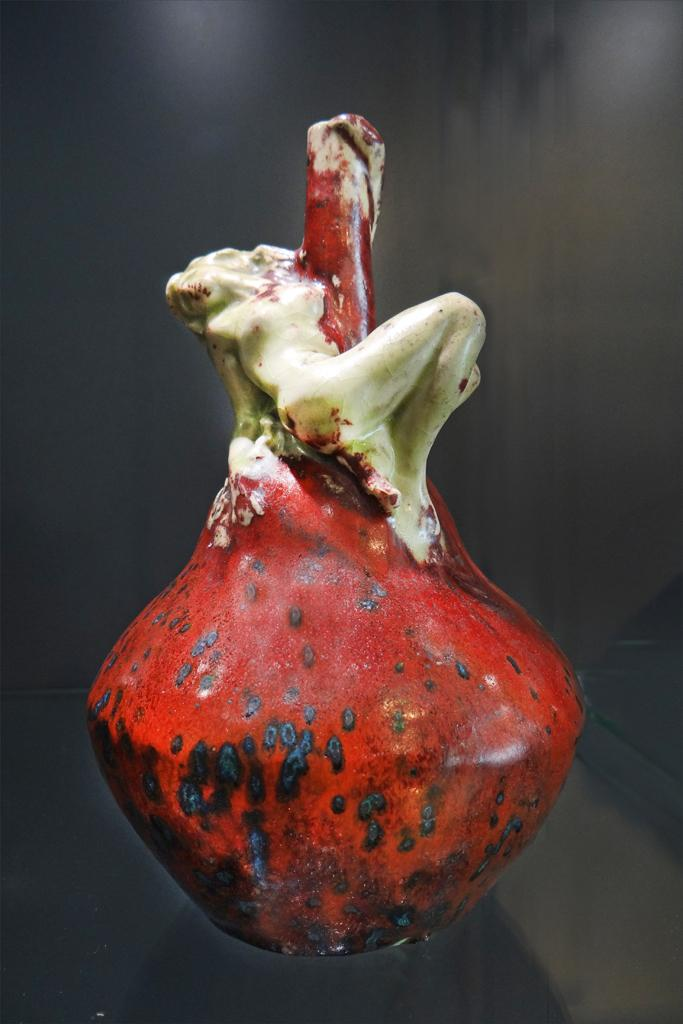What type of object is depicted in the image? There is an object that looks like a stoneware in the image. Can you describe the background in the image? There is a background visible in the image, but no specific details are provided. What type of song is being sung by the person wearing a veil in the image? There is no person wearing a veil or singing a song in the image; it only features an object that looks like a stoneware. 